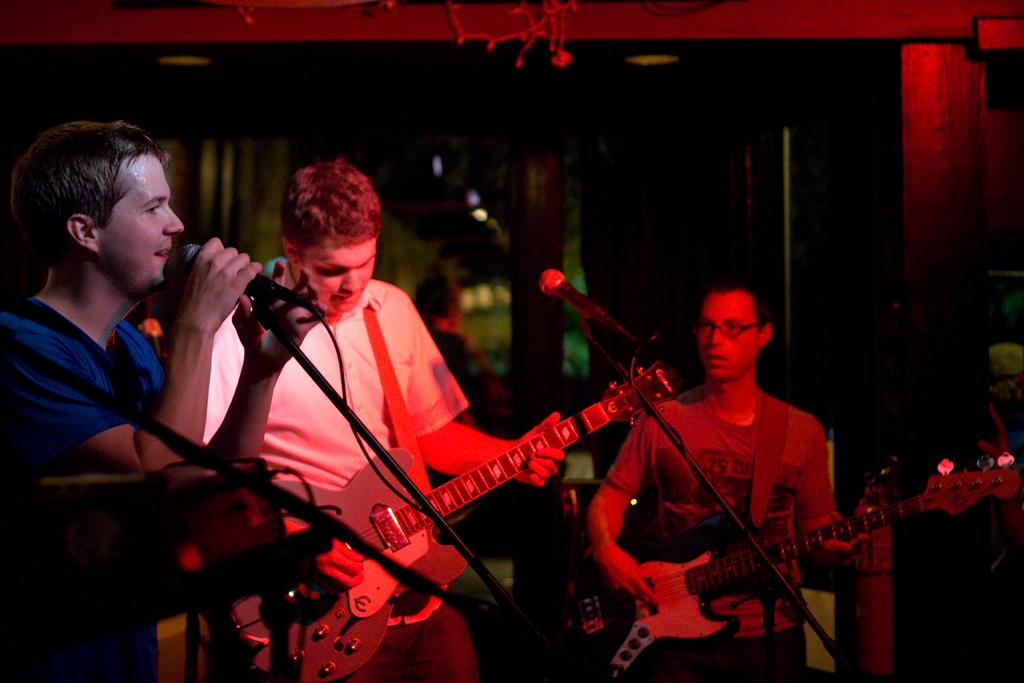How many people are in the image? There are three persons in the image. What are the persons doing in the image? The persons are standing and holding musical instruments and microphones. How many microphones can be seen in the image? There are multiple microphones in the image. What else is present in the image besides the persons and microphones? There are wooden poles in the image. What is the color of the background in the image? The background of the image is dark. What type of engine can be seen in the image? There is no engine present in the image. How many birds are perched on the wooden poles in the image? There are no birds present in the image; only the persons, musical instruments, microphones, and wooden poles can be seen. 